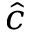<formula> <loc_0><loc_0><loc_500><loc_500>\hat { c }</formula> 